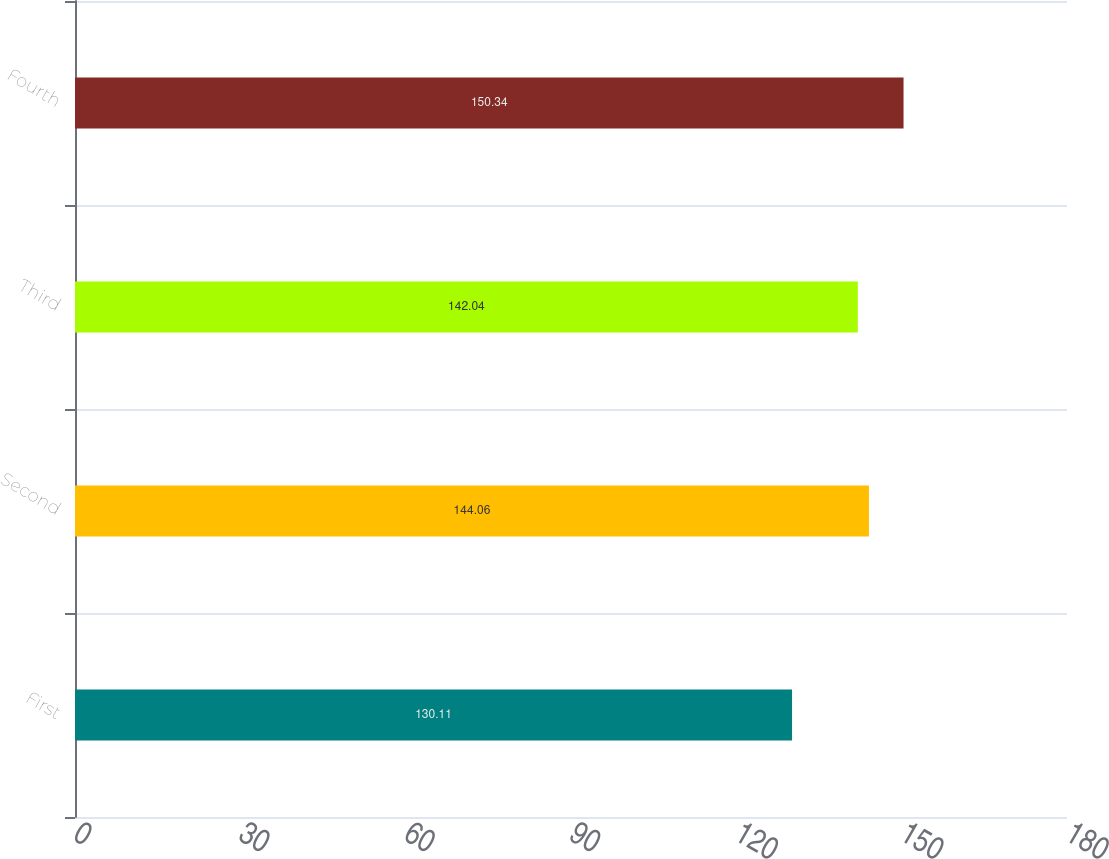Convert chart. <chart><loc_0><loc_0><loc_500><loc_500><bar_chart><fcel>First<fcel>Second<fcel>Third<fcel>Fourth<nl><fcel>130.11<fcel>144.06<fcel>142.04<fcel>150.34<nl></chart> 